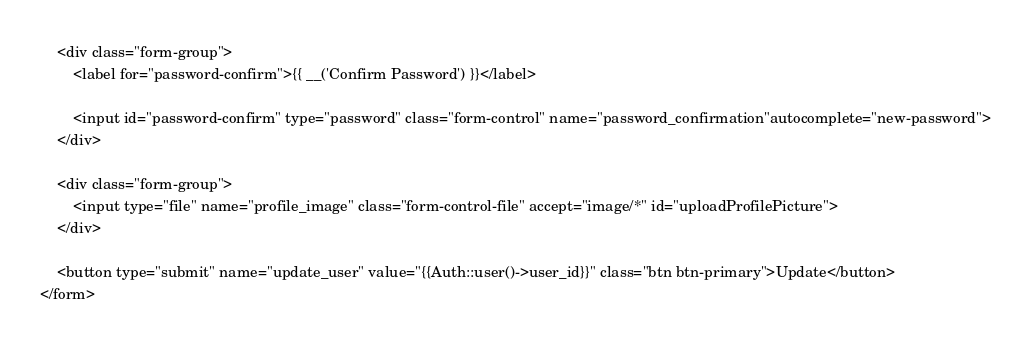<code> <loc_0><loc_0><loc_500><loc_500><_PHP_>
    <div class="form-group">
        <label for="password-confirm">{{ __('Confirm Password') }}</label>

        <input id="password-confirm" type="password" class="form-control" name="password_confirmation"autocomplete="new-password">
    </div>

    <div class="form-group">
        <input type="file" name="profile_image" class="form-control-file" accept="image/*" id="uploadProfilePicture">
    </div>

    <button type="submit" name="update_user" value="{{Auth::user()->user_id}}" class="btn btn-primary">Update</button>
</form>


</code> 